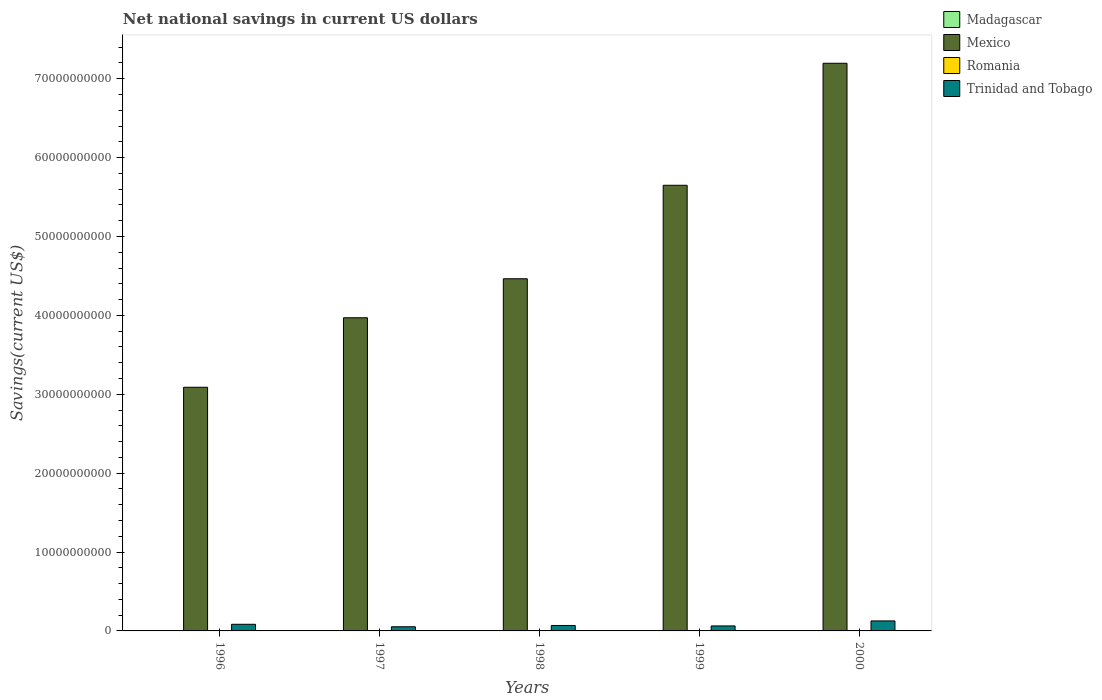How many bars are there on the 2nd tick from the left?
Make the answer very short. 2. How many bars are there on the 1st tick from the right?
Provide a short and direct response. 2. What is the label of the 3rd group of bars from the left?
Make the answer very short. 1998. What is the net national savings in Mexico in 1998?
Your answer should be compact. 4.46e+1. Across all years, what is the maximum net national savings in Mexico?
Provide a short and direct response. 7.20e+1. Across all years, what is the minimum net national savings in Madagascar?
Your answer should be very brief. 0. In which year was the net national savings in Mexico maximum?
Make the answer very short. 2000. What is the difference between the net national savings in Trinidad and Tobago in 1996 and that in 2000?
Your response must be concise. -4.29e+08. What is the average net national savings in Trinidad and Tobago per year?
Provide a short and direct response. 7.92e+08. In the year 1999, what is the difference between the net national savings in Mexico and net national savings in Trinidad and Tobago?
Provide a succinct answer. 5.59e+1. In how many years, is the net national savings in Mexico greater than 56000000000 US$?
Your answer should be very brief. 2. What is the ratio of the net national savings in Mexico in 1997 to that in 1998?
Offer a very short reply. 0.89. Is the difference between the net national savings in Mexico in 1996 and 1999 greater than the difference between the net national savings in Trinidad and Tobago in 1996 and 1999?
Your answer should be very brief. No. What is the difference between the highest and the second highest net national savings in Trinidad and Tobago?
Give a very brief answer. 4.29e+08. What is the difference between the highest and the lowest net national savings in Trinidad and Tobago?
Make the answer very short. 7.40e+08. Is it the case that in every year, the sum of the net national savings in Trinidad and Tobago and net national savings in Madagascar is greater than the sum of net national savings in Mexico and net national savings in Romania?
Make the answer very short. No. Are all the bars in the graph horizontal?
Offer a very short reply. No. How many years are there in the graph?
Give a very brief answer. 5. What is the difference between two consecutive major ticks on the Y-axis?
Your answer should be compact. 1.00e+1. Are the values on the major ticks of Y-axis written in scientific E-notation?
Make the answer very short. No. Where does the legend appear in the graph?
Offer a terse response. Top right. What is the title of the graph?
Provide a short and direct response. Net national savings in current US dollars. What is the label or title of the Y-axis?
Offer a terse response. Savings(current US$). What is the Savings(current US$) of Madagascar in 1996?
Provide a succinct answer. 0. What is the Savings(current US$) of Mexico in 1996?
Provide a short and direct response. 3.09e+1. What is the Savings(current US$) in Romania in 1996?
Give a very brief answer. 0. What is the Savings(current US$) of Trinidad and Tobago in 1996?
Give a very brief answer. 8.40e+08. What is the Savings(current US$) in Mexico in 1997?
Provide a short and direct response. 3.97e+1. What is the Savings(current US$) in Romania in 1997?
Your answer should be compact. 0. What is the Savings(current US$) in Trinidad and Tobago in 1997?
Provide a succinct answer. 5.29e+08. What is the Savings(current US$) in Madagascar in 1998?
Provide a succinct answer. 0. What is the Savings(current US$) of Mexico in 1998?
Offer a terse response. 4.46e+1. What is the Savings(current US$) of Trinidad and Tobago in 1998?
Offer a terse response. 6.90e+08. What is the Savings(current US$) in Mexico in 1999?
Your answer should be very brief. 5.65e+1. What is the Savings(current US$) in Trinidad and Tobago in 1999?
Your answer should be compact. 6.33e+08. What is the Savings(current US$) in Mexico in 2000?
Your answer should be compact. 7.20e+1. What is the Savings(current US$) of Romania in 2000?
Your response must be concise. 0. What is the Savings(current US$) in Trinidad and Tobago in 2000?
Ensure brevity in your answer.  1.27e+09. Across all years, what is the maximum Savings(current US$) of Mexico?
Provide a short and direct response. 7.20e+1. Across all years, what is the maximum Savings(current US$) of Trinidad and Tobago?
Keep it short and to the point. 1.27e+09. Across all years, what is the minimum Savings(current US$) of Mexico?
Ensure brevity in your answer.  3.09e+1. Across all years, what is the minimum Savings(current US$) of Trinidad and Tobago?
Offer a terse response. 5.29e+08. What is the total Savings(current US$) in Mexico in the graph?
Offer a terse response. 2.44e+11. What is the total Savings(current US$) in Trinidad and Tobago in the graph?
Offer a terse response. 3.96e+09. What is the difference between the Savings(current US$) of Mexico in 1996 and that in 1997?
Provide a short and direct response. -8.81e+09. What is the difference between the Savings(current US$) of Trinidad and Tobago in 1996 and that in 1997?
Make the answer very short. 3.11e+08. What is the difference between the Savings(current US$) in Mexico in 1996 and that in 1998?
Make the answer very short. -1.38e+1. What is the difference between the Savings(current US$) of Trinidad and Tobago in 1996 and that in 1998?
Ensure brevity in your answer.  1.50e+08. What is the difference between the Savings(current US$) of Mexico in 1996 and that in 1999?
Your response must be concise. -2.56e+1. What is the difference between the Savings(current US$) of Trinidad and Tobago in 1996 and that in 1999?
Your answer should be compact. 2.07e+08. What is the difference between the Savings(current US$) in Mexico in 1996 and that in 2000?
Keep it short and to the point. -4.11e+1. What is the difference between the Savings(current US$) of Trinidad and Tobago in 1996 and that in 2000?
Make the answer very short. -4.29e+08. What is the difference between the Savings(current US$) of Mexico in 1997 and that in 1998?
Your answer should be compact. -4.95e+09. What is the difference between the Savings(current US$) of Trinidad and Tobago in 1997 and that in 1998?
Offer a terse response. -1.61e+08. What is the difference between the Savings(current US$) in Mexico in 1997 and that in 1999?
Keep it short and to the point. -1.68e+1. What is the difference between the Savings(current US$) of Trinidad and Tobago in 1997 and that in 1999?
Your answer should be very brief. -1.05e+08. What is the difference between the Savings(current US$) in Mexico in 1997 and that in 2000?
Your answer should be very brief. -3.23e+1. What is the difference between the Savings(current US$) of Trinidad and Tobago in 1997 and that in 2000?
Offer a terse response. -7.40e+08. What is the difference between the Savings(current US$) of Mexico in 1998 and that in 1999?
Make the answer very short. -1.19e+1. What is the difference between the Savings(current US$) in Trinidad and Tobago in 1998 and that in 1999?
Give a very brief answer. 5.64e+07. What is the difference between the Savings(current US$) of Mexico in 1998 and that in 2000?
Your response must be concise. -2.73e+1. What is the difference between the Savings(current US$) of Trinidad and Tobago in 1998 and that in 2000?
Give a very brief answer. -5.79e+08. What is the difference between the Savings(current US$) of Mexico in 1999 and that in 2000?
Offer a terse response. -1.55e+1. What is the difference between the Savings(current US$) in Trinidad and Tobago in 1999 and that in 2000?
Give a very brief answer. -6.36e+08. What is the difference between the Savings(current US$) in Mexico in 1996 and the Savings(current US$) in Trinidad and Tobago in 1997?
Provide a succinct answer. 3.04e+1. What is the difference between the Savings(current US$) in Mexico in 1996 and the Savings(current US$) in Trinidad and Tobago in 1998?
Provide a short and direct response. 3.02e+1. What is the difference between the Savings(current US$) in Mexico in 1996 and the Savings(current US$) in Trinidad and Tobago in 1999?
Your response must be concise. 3.03e+1. What is the difference between the Savings(current US$) in Mexico in 1996 and the Savings(current US$) in Trinidad and Tobago in 2000?
Your answer should be very brief. 2.96e+1. What is the difference between the Savings(current US$) in Mexico in 1997 and the Savings(current US$) in Trinidad and Tobago in 1998?
Your response must be concise. 3.90e+1. What is the difference between the Savings(current US$) in Mexico in 1997 and the Savings(current US$) in Trinidad and Tobago in 1999?
Your response must be concise. 3.91e+1. What is the difference between the Savings(current US$) in Mexico in 1997 and the Savings(current US$) in Trinidad and Tobago in 2000?
Keep it short and to the point. 3.84e+1. What is the difference between the Savings(current US$) of Mexico in 1998 and the Savings(current US$) of Trinidad and Tobago in 1999?
Ensure brevity in your answer.  4.40e+1. What is the difference between the Savings(current US$) of Mexico in 1998 and the Savings(current US$) of Trinidad and Tobago in 2000?
Give a very brief answer. 4.34e+1. What is the difference between the Savings(current US$) of Mexico in 1999 and the Savings(current US$) of Trinidad and Tobago in 2000?
Offer a terse response. 5.52e+1. What is the average Savings(current US$) of Madagascar per year?
Keep it short and to the point. 0. What is the average Savings(current US$) of Mexico per year?
Keep it short and to the point. 4.87e+1. What is the average Savings(current US$) of Trinidad and Tobago per year?
Ensure brevity in your answer.  7.92e+08. In the year 1996, what is the difference between the Savings(current US$) of Mexico and Savings(current US$) of Trinidad and Tobago?
Make the answer very short. 3.01e+1. In the year 1997, what is the difference between the Savings(current US$) of Mexico and Savings(current US$) of Trinidad and Tobago?
Make the answer very short. 3.92e+1. In the year 1998, what is the difference between the Savings(current US$) in Mexico and Savings(current US$) in Trinidad and Tobago?
Your answer should be compact. 4.40e+1. In the year 1999, what is the difference between the Savings(current US$) of Mexico and Savings(current US$) of Trinidad and Tobago?
Make the answer very short. 5.59e+1. In the year 2000, what is the difference between the Savings(current US$) of Mexico and Savings(current US$) of Trinidad and Tobago?
Your answer should be compact. 7.07e+1. What is the ratio of the Savings(current US$) of Mexico in 1996 to that in 1997?
Offer a very short reply. 0.78. What is the ratio of the Savings(current US$) in Trinidad and Tobago in 1996 to that in 1997?
Ensure brevity in your answer.  1.59. What is the ratio of the Savings(current US$) in Mexico in 1996 to that in 1998?
Your answer should be very brief. 0.69. What is the ratio of the Savings(current US$) of Trinidad and Tobago in 1996 to that in 1998?
Keep it short and to the point. 1.22. What is the ratio of the Savings(current US$) in Mexico in 1996 to that in 1999?
Offer a very short reply. 0.55. What is the ratio of the Savings(current US$) of Trinidad and Tobago in 1996 to that in 1999?
Offer a terse response. 1.33. What is the ratio of the Savings(current US$) of Mexico in 1996 to that in 2000?
Offer a very short reply. 0.43. What is the ratio of the Savings(current US$) in Trinidad and Tobago in 1996 to that in 2000?
Your answer should be very brief. 0.66. What is the ratio of the Savings(current US$) of Mexico in 1997 to that in 1998?
Offer a very short reply. 0.89. What is the ratio of the Savings(current US$) in Trinidad and Tobago in 1997 to that in 1998?
Your answer should be very brief. 0.77. What is the ratio of the Savings(current US$) of Mexico in 1997 to that in 1999?
Provide a short and direct response. 0.7. What is the ratio of the Savings(current US$) in Trinidad and Tobago in 1997 to that in 1999?
Your response must be concise. 0.83. What is the ratio of the Savings(current US$) in Mexico in 1997 to that in 2000?
Offer a very short reply. 0.55. What is the ratio of the Savings(current US$) of Trinidad and Tobago in 1997 to that in 2000?
Make the answer very short. 0.42. What is the ratio of the Savings(current US$) of Mexico in 1998 to that in 1999?
Provide a short and direct response. 0.79. What is the ratio of the Savings(current US$) of Trinidad and Tobago in 1998 to that in 1999?
Offer a terse response. 1.09. What is the ratio of the Savings(current US$) of Mexico in 1998 to that in 2000?
Provide a succinct answer. 0.62. What is the ratio of the Savings(current US$) of Trinidad and Tobago in 1998 to that in 2000?
Give a very brief answer. 0.54. What is the ratio of the Savings(current US$) of Mexico in 1999 to that in 2000?
Offer a terse response. 0.79. What is the ratio of the Savings(current US$) of Trinidad and Tobago in 1999 to that in 2000?
Make the answer very short. 0.5. What is the difference between the highest and the second highest Savings(current US$) in Mexico?
Provide a short and direct response. 1.55e+1. What is the difference between the highest and the second highest Savings(current US$) in Trinidad and Tobago?
Ensure brevity in your answer.  4.29e+08. What is the difference between the highest and the lowest Savings(current US$) of Mexico?
Provide a short and direct response. 4.11e+1. What is the difference between the highest and the lowest Savings(current US$) in Trinidad and Tobago?
Give a very brief answer. 7.40e+08. 